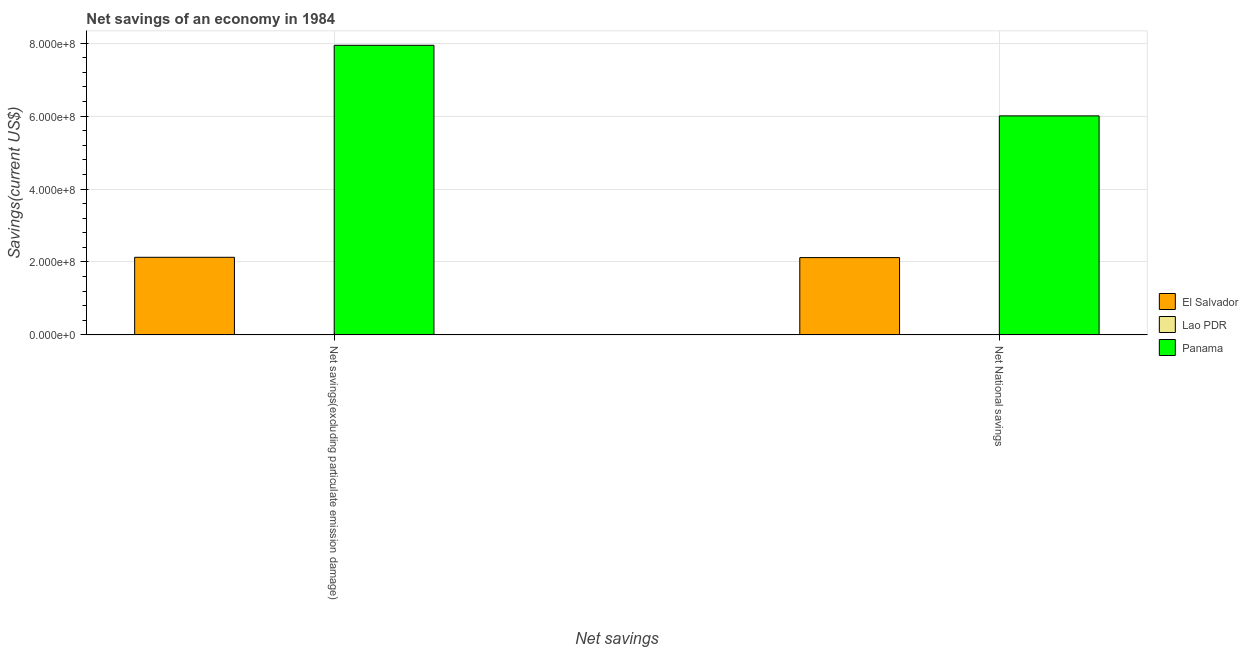Are the number of bars per tick equal to the number of legend labels?
Offer a very short reply. No. How many bars are there on the 2nd tick from the left?
Give a very brief answer. 2. What is the label of the 1st group of bars from the left?
Give a very brief answer. Net savings(excluding particulate emission damage). What is the net national savings in El Salvador?
Offer a terse response. 2.12e+08. Across all countries, what is the maximum net savings(excluding particulate emission damage)?
Your response must be concise. 7.94e+08. In which country was the net national savings maximum?
Make the answer very short. Panama. What is the total net national savings in the graph?
Provide a short and direct response. 8.13e+08. What is the difference between the net savings(excluding particulate emission damage) in El Salvador and that in Panama?
Provide a short and direct response. -5.81e+08. What is the difference between the net savings(excluding particulate emission damage) in El Salvador and the net national savings in Lao PDR?
Give a very brief answer. 2.13e+08. What is the average net national savings per country?
Provide a succinct answer. 2.71e+08. What is the difference between the net national savings and net savings(excluding particulate emission damage) in El Salvador?
Give a very brief answer. -7.86e+05. What is the ratio of the net savings(excluding particulate emission damage) in Panama to that in El Salvador?
Your response must be concise. 3.73. Are the values on the major ticks of Y-axis written in scientific E-notation?
Your response must be concise. Yes. Does the graph contain any zero values?
Ensure brevity in your answer.  Yes. Does the graph contain grids?
Give a very brief answer. Yes. What is the title of the graph?
Make the answer very short. Net savings of an economy in 1984. What is the label or title of the X-axis?
Give a very brief answer. Net savings. What is the label or title of the Y-axis?
Keep it short and to the point. Savings(current US$). What is the Savings(current US$) in El Salvador in Net savings(excluding particulate emission damage)?
Keep it short and to the point. 2.13e+08. What is the Savings(current US$) in Panama in Net savings(excluding particulate emission damage)?
Give a very brief answer. 7.94e+08. What is the Savings(current US$) of El Salvador in Net National savings?
Your answer should be compact. 2.12e+08. What is the Savings(current US$) of Lao PDR in Net National savings?
Your answer should be very brief. 0. What is the Savings(current US$) of Panama in Net National savings?
Keep it short and to the point. 6.01e+08. Across all Net savings, what is the maximum Savings(current US$) of El Salvador?
Your answer should be compact. 2.13e+08. Across all Net savings, what is the maximum Savings(current US$) in Panama?
Ensure brevity in your answer.  7.94e+08. Across all Net savings, what is the minimum Savings(current US$) of El Salvador?
Keep it short and to the point. 2.12e+08. Across all Net savings, what is the minimum Savings(current US$) of Panama?
Provide a short and direct response. 6.01e+08. What is the total Savings(current US$) of El Salvador in the graph?
Offer a terse response. 4.25e+08. What is the total Savings(current US$) in Panama in the graph?
Provide a succinct answer. 1.39e+09. What is the difference between the Savings(current US$) of El Salvador in Net savings(excluding particulate emission damage) and that in Net National savings?
Your answer should be compact. 7.86e+05. What is the difference between the Savings(current US$) in Panama in Net savings(excluding particulate emission damage) and that in Net National savings?
Provide a short and direct response. 1.94e+08. What is the difference between the Savings(current US$) of El Salvador in Net savings(excluding particulate emission damage) and the Savings(current US$) of Panama in Net National savings?
Give a very brief answer. -3.88e+08. What is the average Savings(current US$) of El Salvador per Net savings?
Your response must be concise. 2.12e+08. What is the average Savings(current US$) in Lao PDR per Net savings?
Make the answer very short. 0. What is the average Savings(current US$) of Panama per Net savings?
Keep it short and to the point. 6.97e+08. What is the difference between the Savings(current US$) in El Salvador and Savings(current US$) in Panama in Net savings(excluding particulate emission damage)?
Ensure brevity in your answer.  -5.81e+08. What is the difference between the Savings(current US$) of El Salvador and Savings(current US$) of Panama in Net National savings?
Provide a succinct answer. -3.89e+08. What is the ratio of the Savings(current US$) of Panama in Net savings(excluding particulate emission damage) to that in Net National savings?
Provide a short and direct response. 1.32. What is the difference between the highest and the second highest Savings(current US$) in El Salvador?
Offer a terse response. 7.86e+05. What is the difference between the highest and the second highest Savings(current US$) of Panama?
Your answer should be very brief. 1.94e+08. What is the difference between the highest and the lowest Savings(current US$) in El Salvador?
Your answer should be very brief. 7.86e+05. What is the difference between the highest and the lowest Savings(current US$) in Panama?
Provide a succinct answer. 1.94e+08. 